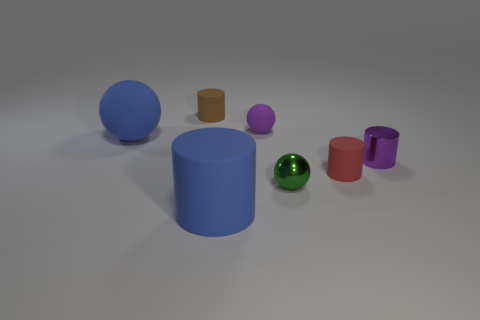Are there any patterns or themes evident in the assortment of objects? The objects do not seem to follow a specific pattern or theme. The assortment includes objects of different colors, sizes, and materials, which suggests an arbitrary or random collection rather than a deliberate pattern. 